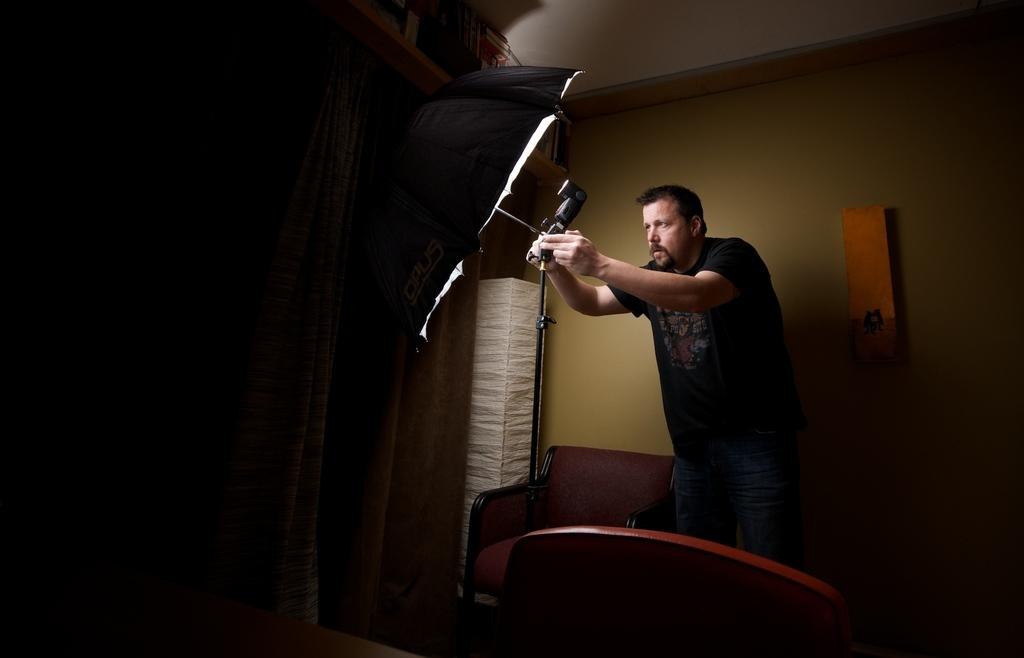Who is present in the image? There is a man in the image. What is the man holding in the image? The man is holding an umbrella. What type of furniture can be seen in the image? There are chairs in the image. What is the background of the image made up of? There is a wall in the image. What type of trail can be seen in the image? There is no trail present in the image. 